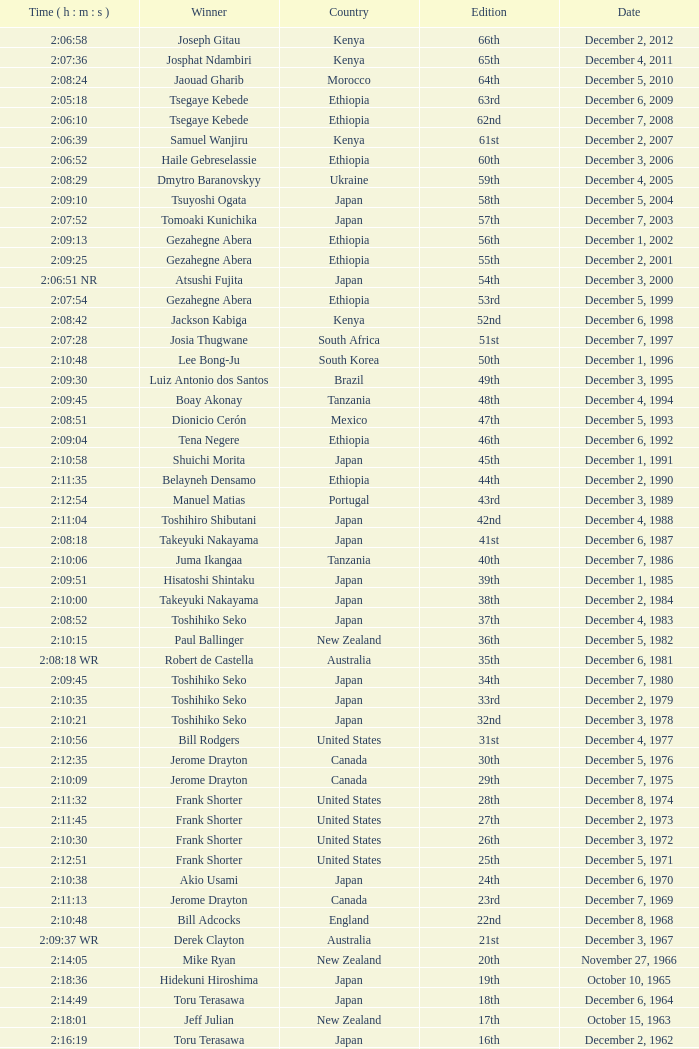Who was the winner of the 23rd Edition? Jerome Drayton. 